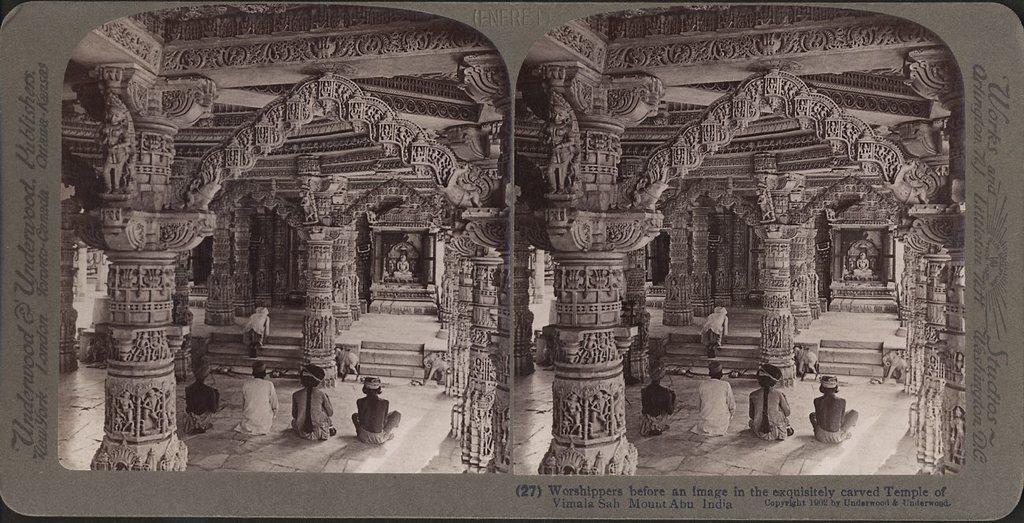Can you describe this image briefly? This is a poster having two similar images and texts. In these two images, there are four children sitting on the floor of the temple which is having sculptures on the pillars and a statue arranged. 